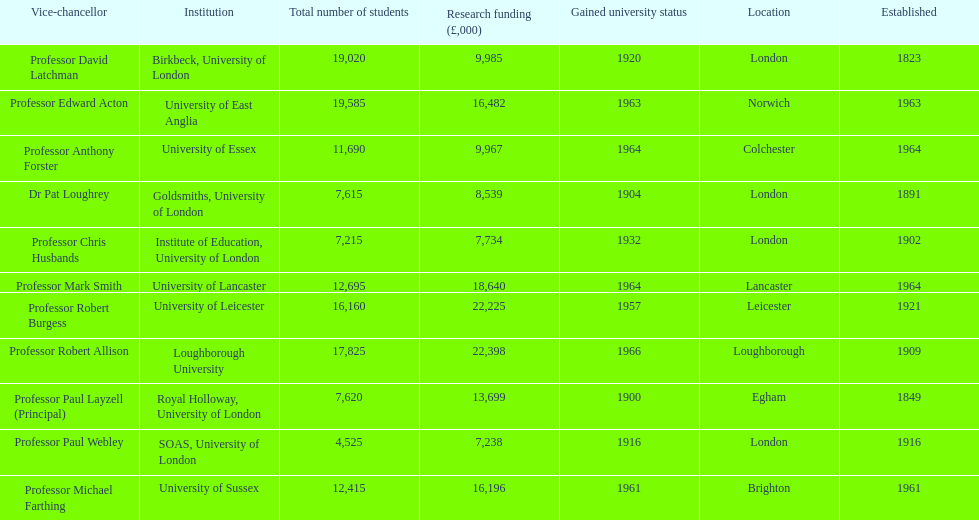How many of the institutions are located in london? 4. 